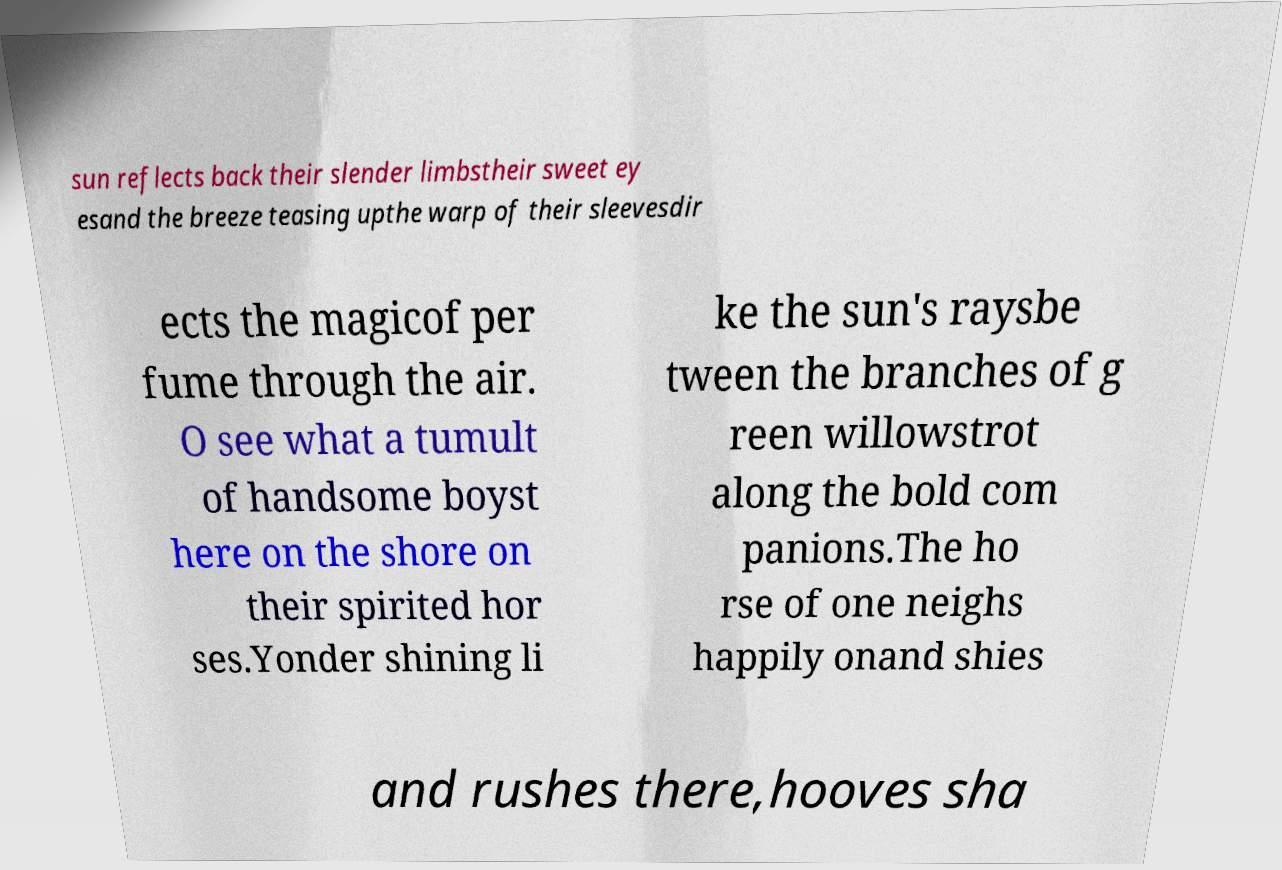What messages or text are displayed in this image? I need them in a readable, typed format. sun reflects back their slender limbstheir sweet ey esand the breeze teasing upthe warp of their sleevesdir ects the magicof per fume through the air. O see what a tumult of handsome boyst here on the shore on their spirited hor ses.Yonder shining li ke the sun's raysbe tween the branches of g reen willowstrot along the bold com panions.The ho rse of one neighs happily onand shies and rushes there,hooves sha 